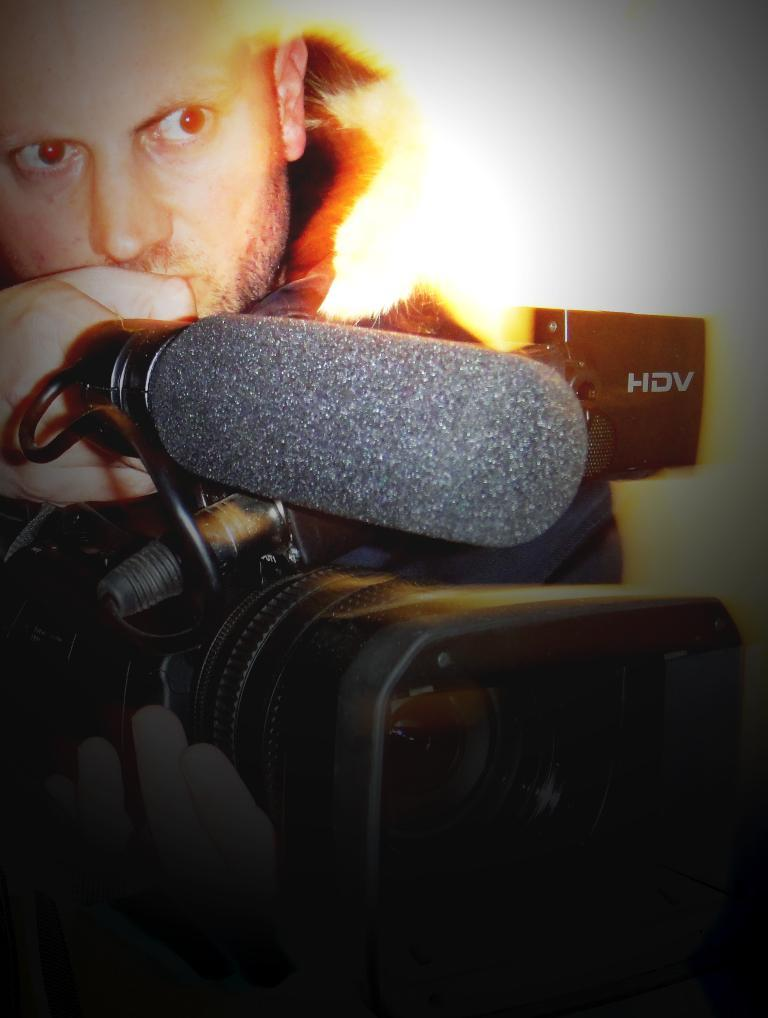Who is present in the image? There is a man in the image. What is the man holding in the image? The man is holding a camera. What is the color of the camera? The camera is black in color. What can be seen on the right side of the image? There is a black object on the right side of the image. What is written on the black object? "HIV" is written on the black object. What type of apparatus is the man using to fly in the image? There is no apparatus for flying present in the image; the man is holding a camera. Can you describe the airplane in the image? There is no airplane present in the image. What type of skin condition does the man have in the image? There is no indication of any skin condition in the image; the focus is on the man holding a camera and the black object with "HIV" written on it. 